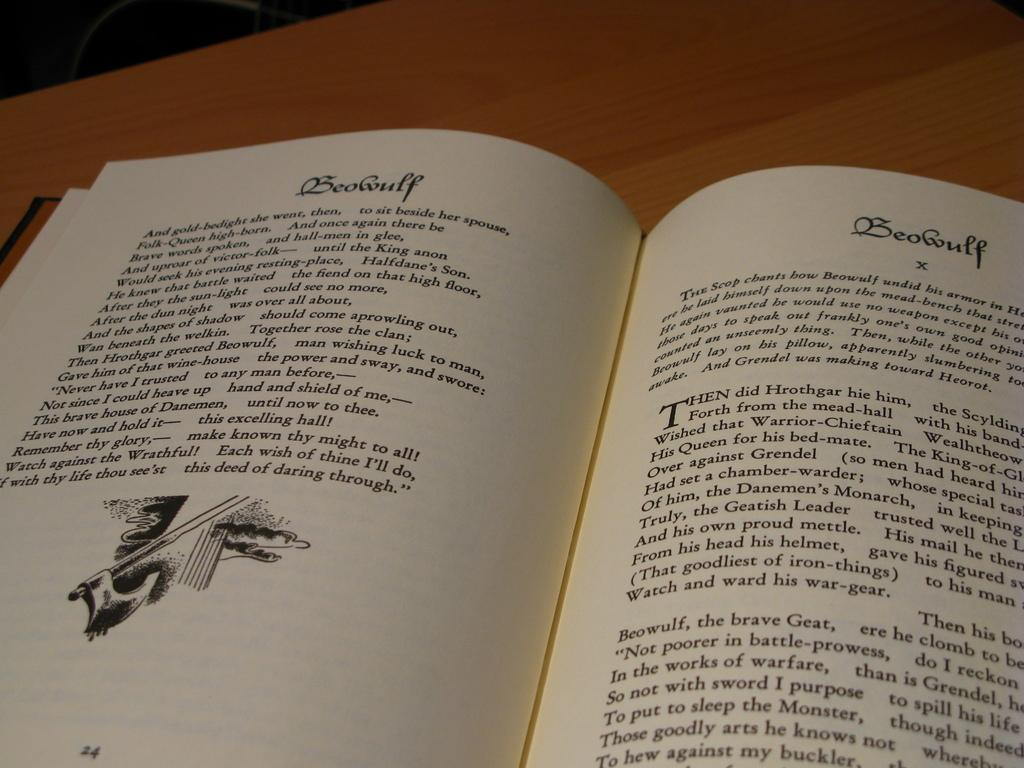<image>
Create a compact narrative representing the image presented. Book titled "Beowulf" open on page 24 and 25. 